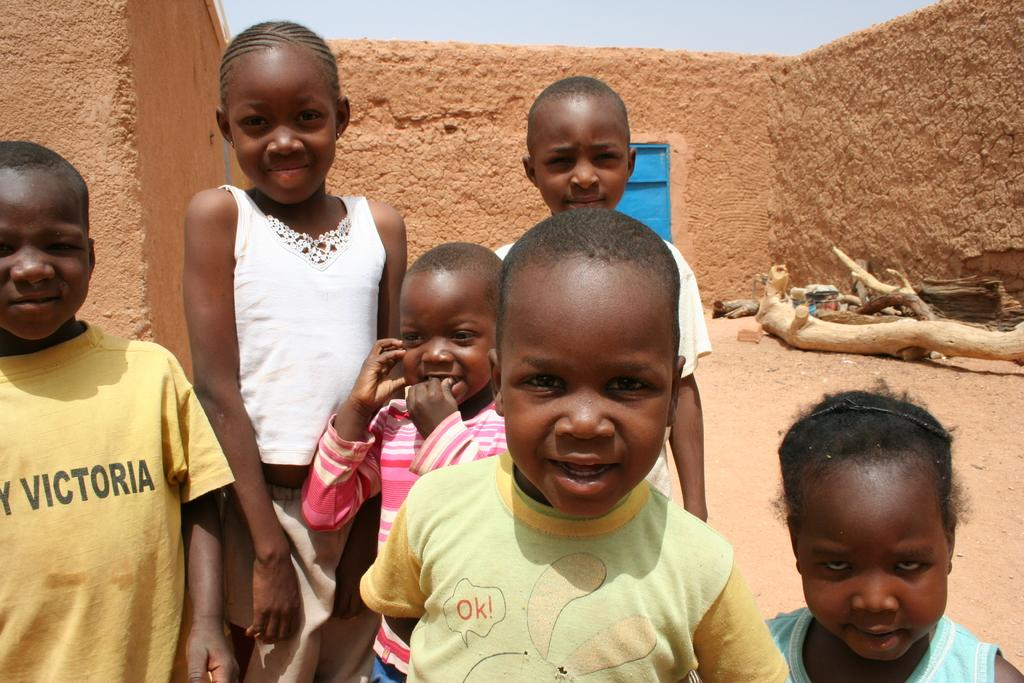What are the kids doing in the image? The kids are standing in the image. What is the expression on the kids' faces? The kids are smiling in the image. What type of natural elements can be seen in the image? There are branches visible in the image. What type of structure is present in the image? There are sand walls in the image. What is visible in the background of the image? The sky is visible in the background of the image. How many legs can be seen on the geese in the image? There are no geese present in the image, so the number of legs cannot be determined. 